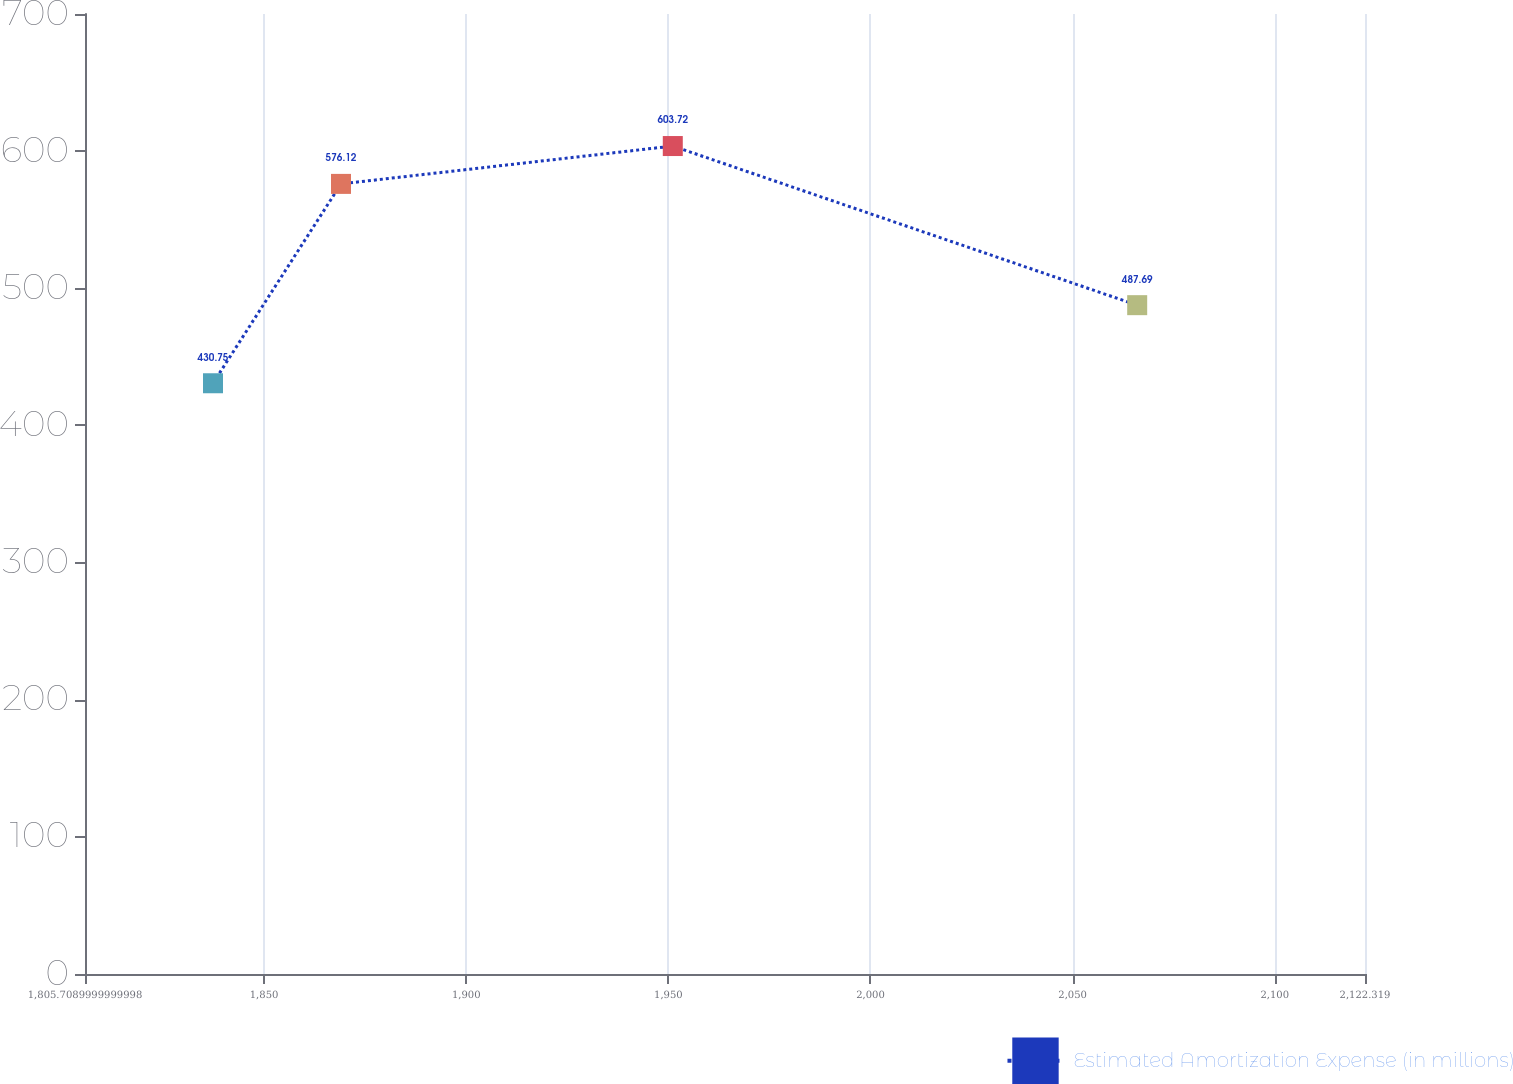Convert chart to OTSL. <chart><loc_0><loc_0><loc_500><loc_500><line_chart><ecel><fcel>Estimated Amortization Expense (in millions)<nl><fcel>1837.37<fcel>430.75<nl><fcel>1869.03<fcel>576.12<nl><fcel>1951.1<fcel>603.72<nl><fcel>2065.97<fcel>487.69<nl><fcel>2153.98<fcel>541.3<nl></chart> 